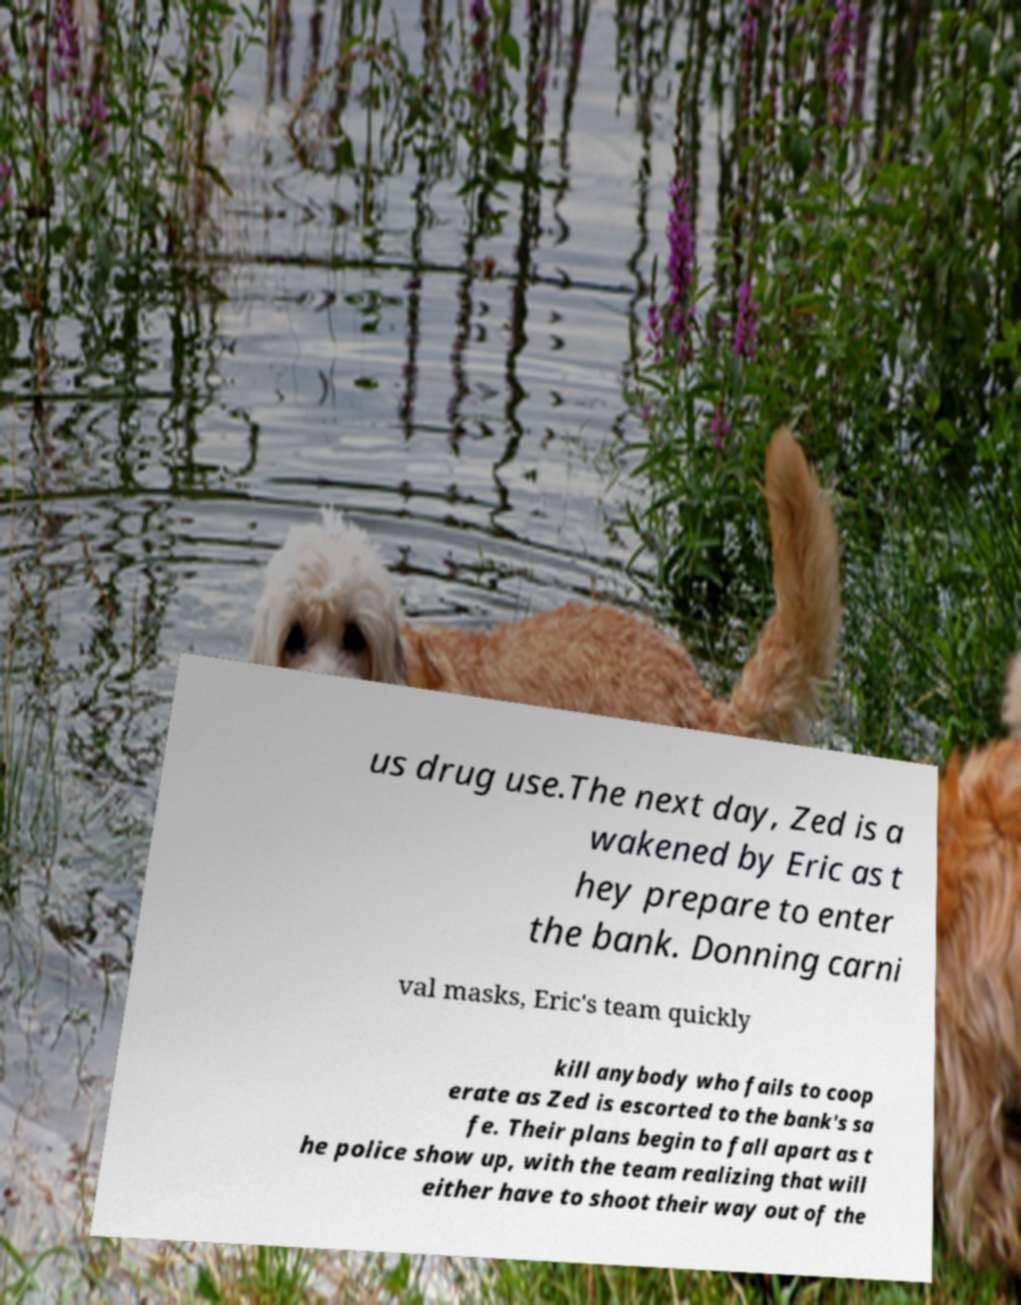Could you assist in decoding the text presented in this image and type it out clearly? us drug use.The next day, Zed is a wakened by Eric as t hey prepare to enter the bank. Donning carni val masks, Eric's team quickly kill anybody who fails to coop erate as Zed is escorted to the bank's sa fe. Their plans begin to fall apart as t he police show up, with the team realizing that will either have to shoot their way out of the 